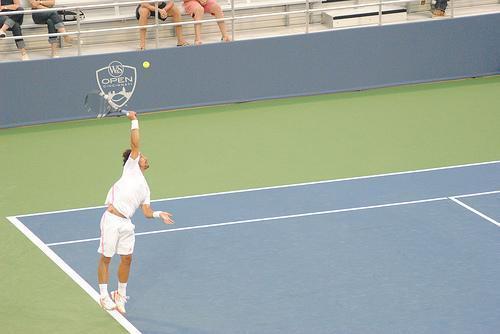How many players are seen?
Give a very brief answer. 1. 